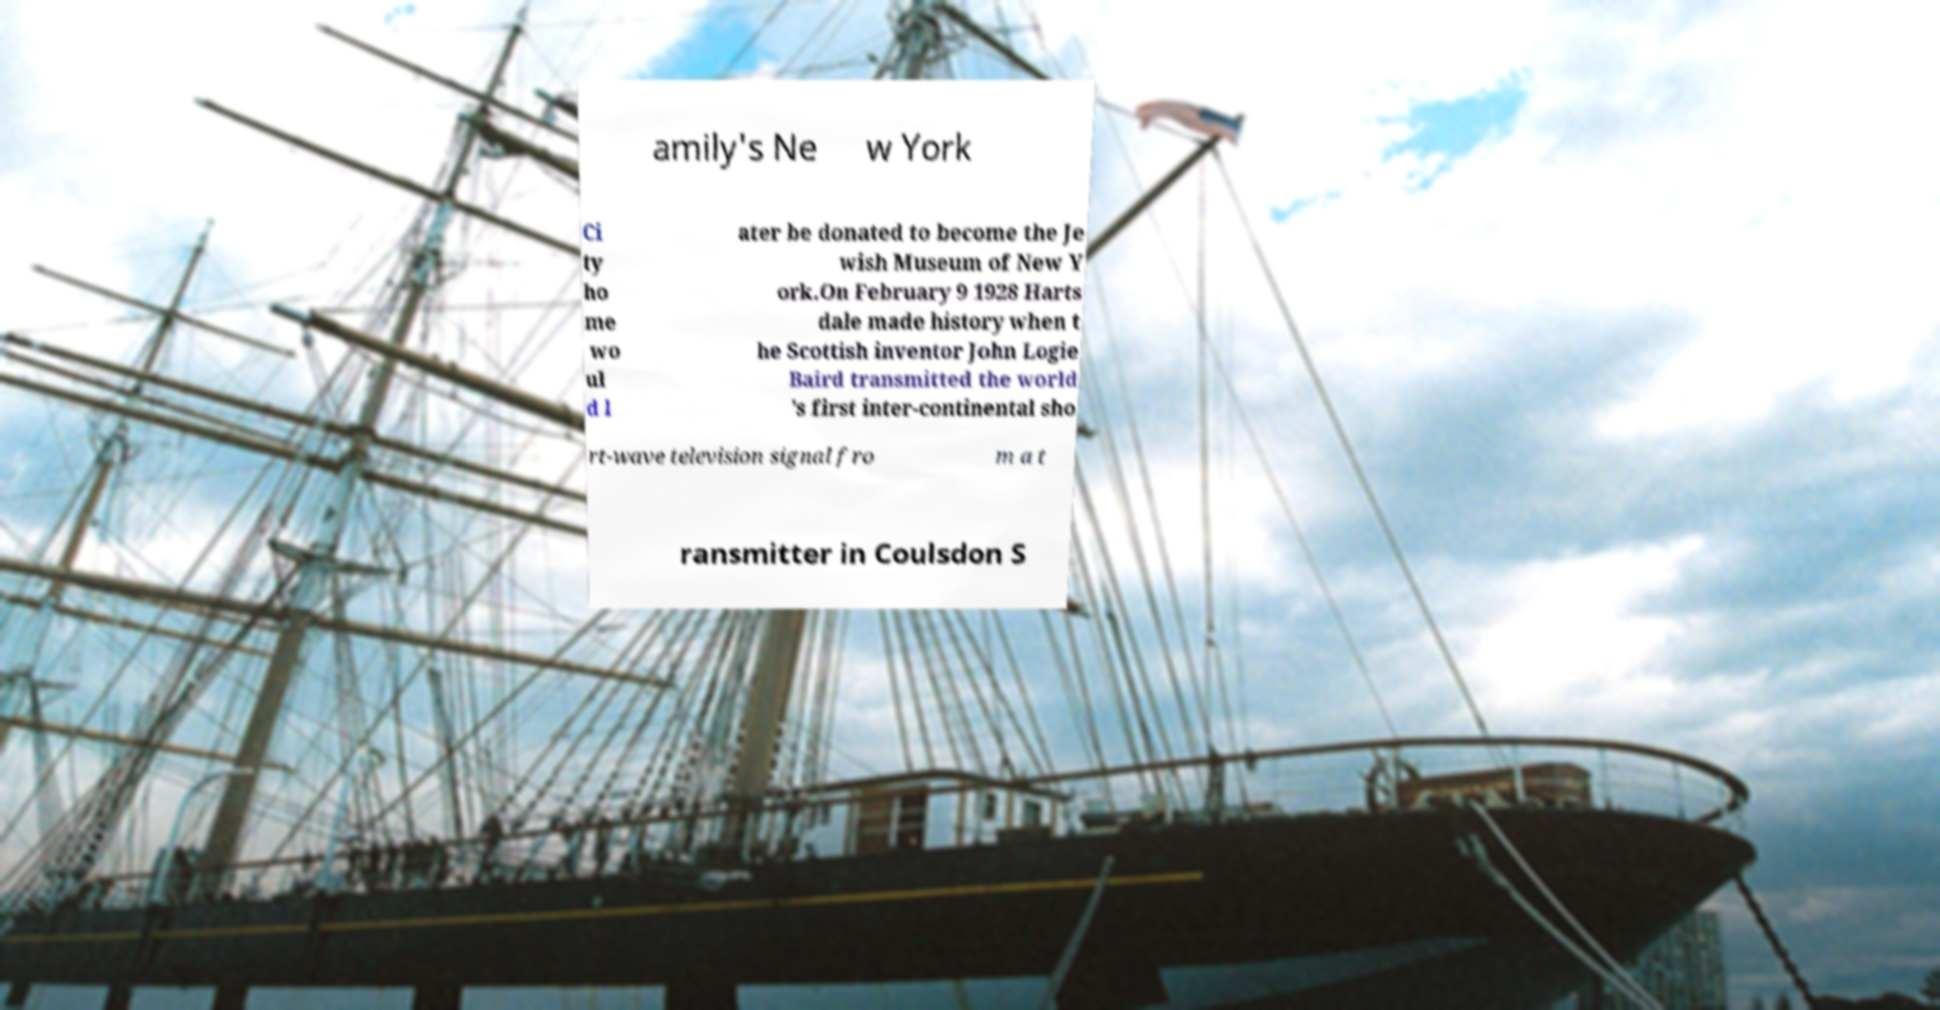Could you assist in decoding the text presented in this image and type it out clearly? amily's Ne w York Ci ty ho me wo ul d l ater be donated to become the Je wish Museum of New Y ork.On February 9 1928 Harts dale made history when t he Scottish inventor John Logie Baird transmitted the world 's first inter-continental sho rt-wave television signal fro m a t ransmitter in Coulsdon S 